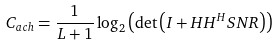<formula> <loc_0><loc_0><loc_500><loc_500>C _ { a c h } = \frac { 1 } { L + 1 } \log _ { 2 } \left ( { \det \left ( { { I } + { H H } ^ { H } S N R } \right ) } \right )</formula> 